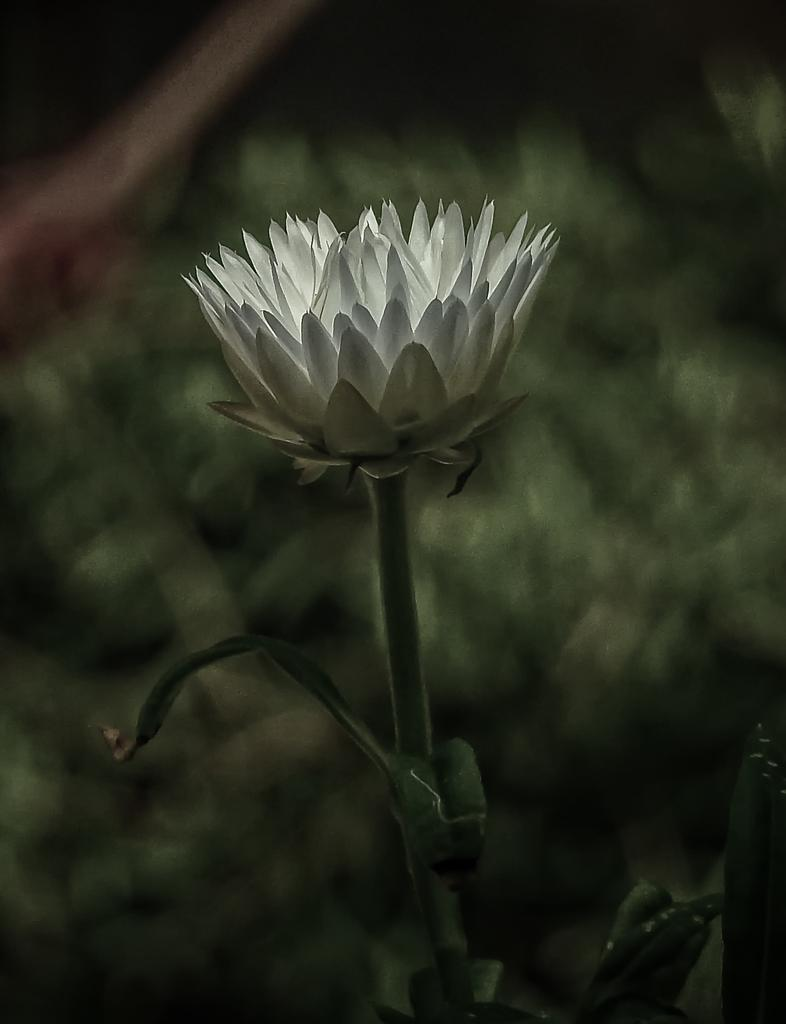What type of flower is in the image? There is a rose in the image. What color is the rose? The rose is white in color. Can you describe any part of the rose besides the petals? The stem of the rose is visible in the image. How would you describe the background of the image? The background of the image is blurred. What flavor of ice cream is being served in the yard with the cows? There is no ice cream or cows mentioned in the image, which only features a white rose with a visible stem and a blurred background. 